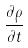Convert formula to latex. <formula><loc_0><loc_0><loc_500><loc_500>\frac { \partial \rho } { \partial t }</formula> 